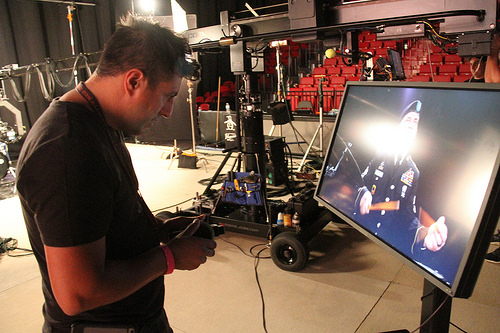<image>
Is the man in front of the tv? Yes. The man is positioned in front of the tv, appearing closer to the camera viewpoint. 